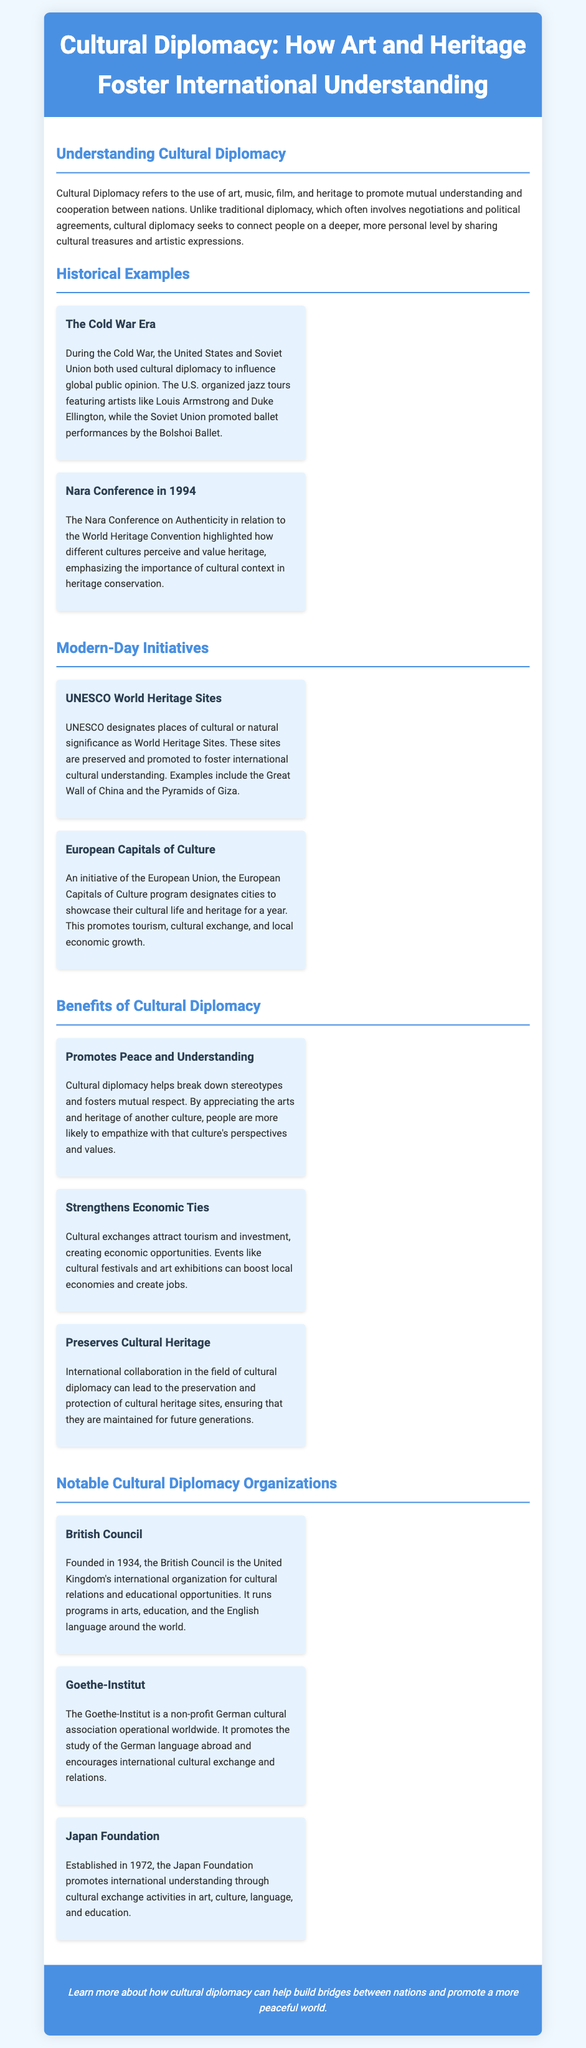What is cultural diplomacy? Cultural diplomacy refers to the use of art, music, film, and heritage to promote mutual understanding and cooperation between nations.
Answer: Use of art, music, film, and heritage Which two countries used cultural diplomacy during the Cold War? The document mentions the United States and Soviet Union both used cultural diplomacy to influence global public opinion.
Answer: United States and Soviet Union What year did the Nara Conference take place? The Nara Conference is mentioned in the document as occurring in 1994.
Answer: 1994 What is a benefit of cultural diplomacy regarding stereotypes? The document states that cultural diplomacy helps break down stereotypes and fosters mutual respect.
Answer: Break down stereotypes What does UNESCO designate as World Heritage Sites? UNESCO designates places of cultural or natural significance as World Heritage Sites.
Answer: Places of cultural or natural significance Which organization promotes the study of the German language abroad? The document identifies the Goethe-Institut as a non-profit German cultural association that promotes the study of the German language abroad.
Answer: Goethe-Institut What event does the European Capitals of Culture program showcase? The program designates cities to showcase their cultural life and heritage for a year.
Answer: Cities to showcase cultural life How many benefits of cultural diplomacy are mentioned in the document? The document lists three specific benefits of cultural diplomacy.
Answer: Three benefits What year was the Japan Foundation established? The document states that the Japan Foundation was established in 1972.
Answer: 1972 